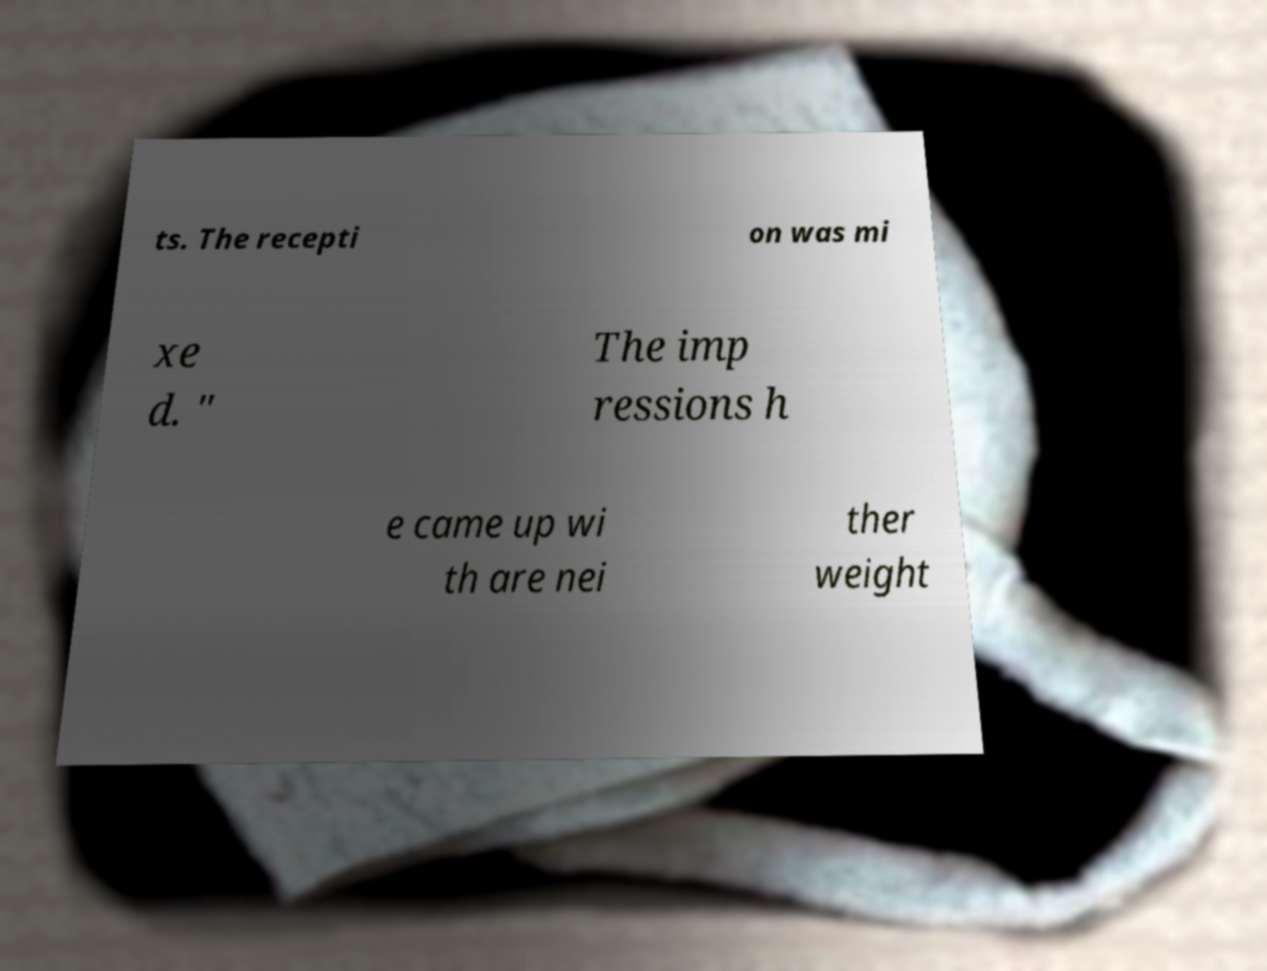What messages or text are displayed in this image? I need them in a readable, typed format. ts. The recepti on was mi xe d. " The imp ressions h e came up wi th are nei ther weight 